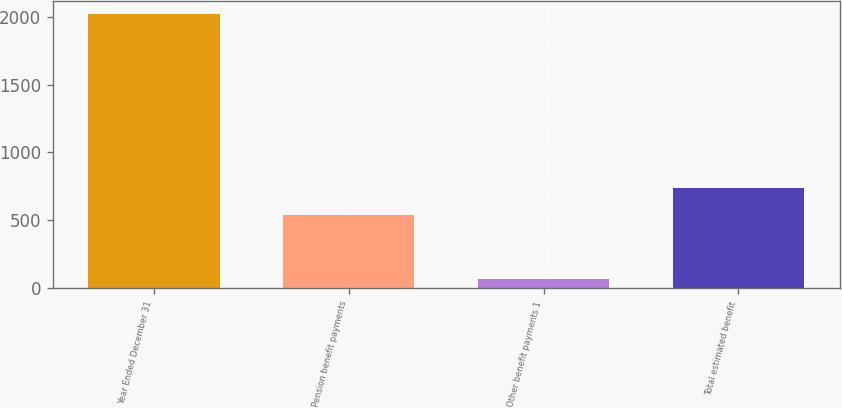Convert chart. <chart><loc_0><loc_0><loc_500><loc_500><bar_chart><fcel>Year Ended December 31<fcel>Pension benefit payments<fcel>Other benefit payments 1<fcel>Total estimated benefit<nl><fcel>2017<fcel>542<fcel>66<fcel>737.1<nl></chart> 